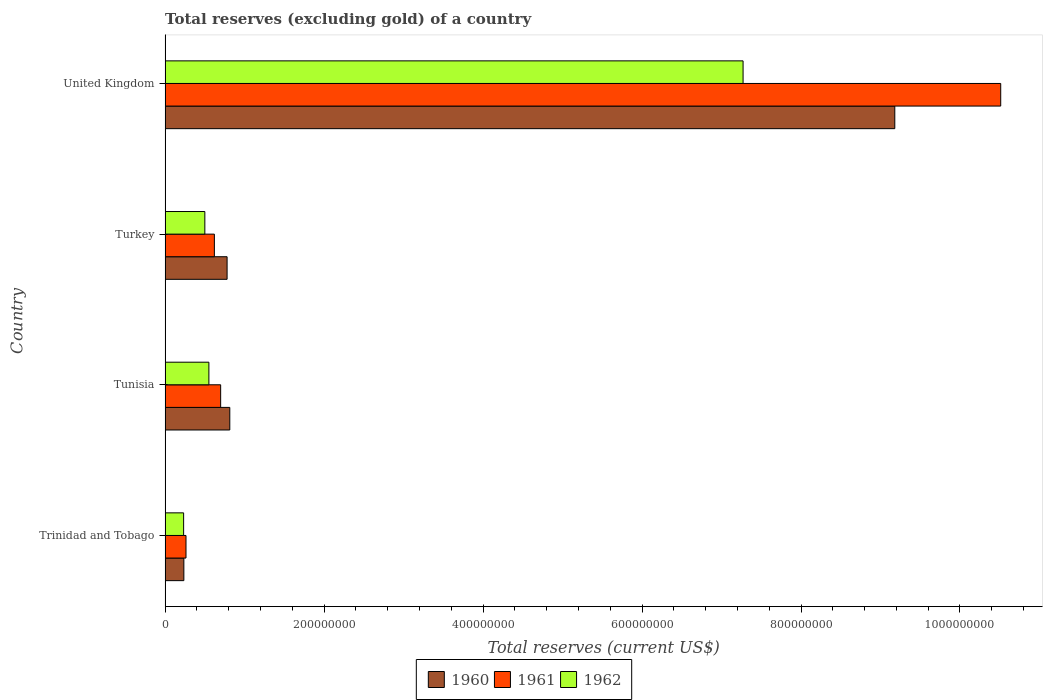How many different coloured bars are there?
Provide a short and direct response. 3. Are the number of bars on each tick of the Y-axis equal?
Provide a short and direct response. Yes. What is the total reserves (excluding gold) in 1962 in United Kingdom?
Keep it short and to the point. 7.27e+08. Across all countries, what is the maximum total reserves (excluding gold) in 1962?
Give a very brief answer. 7.27e+08. Across all countries, what is the minimum total reserves (excluding gold) in 1962?
Keep it short and to the point. 2.33e+07. In which country was the total reserves (excluding gold) in 1960 minimum?
Provide a succinct answer. Trinidad and Tobago. What is the total total reserves (excluding gold) in 1960 in the graph?
Your answer should be very brief. 1.10e+09. What is the difference between the total reserves (excluding gold) in 1962 in Trinidad and Tobago and that in Tunisia?
Make the answer very short. -3.18e+07. What is the difference between the total reserves (excluding gold) in 1960 in Tunisia and the total reserves (excluding gold) in 1962 in Trinidad and Tobago?
Offer a terse response. 5.81e+07. What is the average total reserves (excluding gold) in 1960 per country?
Give a very brief answer. 2.75e+08. What is the difference between the total reserves (excluding gold) in 1960 and total reserves (excluding gold) in 1962 in Turkey?
Make the answer very short. 2.80e+07. What is the ratio of the total reserves (excluding gold) in 1961 in Trinidad and Tobago to that in Tunisia?
Give a very brief answer. 0.38. Is the total reserves (excluding gold) in 1960 in Trinidad and Tobago less than that in Tunisia?
Provide a short and direct response. Yes. Is the difference between the total reserves (excluding gold) in 1960 in Trinidad and Tobago and Turkey greater than the difference between the total reserves (excluding gold) in 1962 in Trinidad and Tobago and Turkey?
Offer a very short reply. No. What is the difference between the highest and the second highest total reserves (excluding gold) in 1962?
Offer a terse response. 6.72e+08. What is the difference between the highest and the lowest total reserves (excluding gold) in 1961?
Your response must be concise. 1.02e+09. In how many countries, is the total reserves (excluding gold) in 1962 greater than the average total reserves (excluding gold) in 1962 taken over all countries?
Offer a terse response. 1. Is the sum of the total reserves (excluding gold) in 1962 in Trinidad and Tobago and United Kingdom greater than the maximum total reserves (excluding gold) in 1960 across all countries?
Offer a very short reply. No. How many bars are there?
Your response must be concise. 12. Are all the bars in the graph horizontal?
Your answer should be very brief. Yes. How many countries are there in the graph?
Your answer should be very brief. 4. What is the difference between two consecutive major ticks on the X-axis?
Keep it short and to the point. 2.00e+08. Are the values on the major ticks of X-axis written in scientific E-notation?
Provide a succinct answer. No. Does the graph contain grids?
Make the answer very short. No. Where does the legend appear in the graph?
Provide a succinct answer. Bottom center. How are the legend labels stacked?
Give a very brief answer. Horizontal. What is the title of the graph?
Ensure brevity in your answer.  Total reserves (excluding gold) of a country. Does "1989" appear as one of the legend labels in the graph?
Provide a short and direct response. No. What is the label or title of the X-axis?
Ensure brevity in your answer.  Total reserves (current US$). What is the label or title of the Y-axis?
Keep it short and to the point. Country. What is the Total reserves (current US$) of 1960 in Trinidad and Tobago?
Keep it short and to the point. 2.36e+07. What is the Total reserves (current US$) in 1961 in Trinidad and Tobago?
Offer a very short reply. 2.63e+07. What is the Total reserves (current US$) in 1962 in Trinidad and Tobago?
Keep it short and to the point. 2.33e+07. What is the Total reserves (current US$) of 1960 in Tunisia?
Your response must be concise. 8.14e+07. What is the Total reserves (current US$) in 1961 in Tunisia?
Your answer should be compact. 6.99e+07. What is the Total reserves (current US$) in 1962 in Tunisia?
Your response must be concise. 5.51e+07. What is the Total reserves (current US$) in 1960 in Turkey?
Ensure brevity in your answer.  7.80e+07. What is the Total reserves (current US$) of 1961 in Turkey?
Provide a short and direct response. 6.20e+07. What is the Total reserves (current US$) of 1960 in United Kingdom?
Provide a succinct answer. 9.18e+08. What is the Total reserves (current US$) in 1961 in United Kingdom?
Your answer should be very brief. 1.05e+09. What is the Total reserves (current US$) of 1962 in United Kingdom?
Provide a succinct answer. 7.27e+08. Across all countries, what is the maximum Total reserves (current US$) of 1960?
Your answer should be very brief. 9.18e+08. Across all countries, what is the maximum Total reserves (current US$) in 1961?
Provide a succinct answer. 1.05e+09. Across all countries, what is the maximum Total reserves (current US$) of 1962?
Provide a short and direct response. 7.27e+08. Across all countries, what is the minimum Total reserves (current US$) in 1960?
Provide a short and direct response. 2.36e+07. Across all countries, what is the minimum Total reserves (current US$) in 1961?
Keep it short and to the point. 2.63e+07. Across all countries, what is the minimum Total reserves (current US$) in 1962?
Make the answer very short. 2.33e+07. What is the total Total reserves (current US$) in 1960 in the graph?
Your answer should be compact. 1.10e+09. What is the total Total reserves (current US$) of 1961 in the graph?
Offer a very short reply. 1.21e+09. What is the total Total reserves (current US$) of 1962 in the graph?
Your answer should be compact. 8.56e+08. What is the difference between the Total reserves (current US$) of 1960 in Trinidad and Tobago and that in Tunisia?
Provide a short and direct response. -5.78e+07. What is the difference between the Total reserves (current US$) in 1961 in Trinidad and Tobago and that in Tunisia?
Your response must be concise. -4.36e+07. What is the difference between the Total reserves (current US$) in 1962 in Trinidad and Tobago and that in Tunisia?
Your response must be concise. -3.18e+07. What is the difference between the Total reserves (current US$) in 1960 in Trinidad and Tobago and that in Turkey?
Ensure brevity in your answer.  -5.44e+07. What is the difference between the Total reserves (current US$) in 1961 in Trinidad and Tobago and that in Turkey?
Provide a succinct answer. -3.57e+07. What is the difference between the Total reserves (current US$) of 1962 in Trinidad and Tobago and that in Turkey?
Ensure brevity in your answer.  -2.67e+07. What is the difference between the Total reserves (current US$) in 1960 in Trinidad and Tobago and that in United Kingdom?
Your answer should be very brief. -8.94e+08. What is the difference between the Total reserves (current US$) in 1961 in Trinidad and Tobago and that in United Kingdom?
Your answer should be very brief. -1.02e+09. What is the difference between the Total reserves (current US$) of 1962 in Trinidad and Tobago and that in United Kingdom?
Make the answer very short. -7.04e+08. What is the difference between the Total reserves (current US$) of 1960 in Tunisia and that in Turkey?
Your answer should be compact. 3.40e+06. What is the difference between the Total reserves (current US$) of 1961 in Tunisia and that in Turkey?
Offer a terse response. 7.90e+06. What is the difference between the Total reserves (current US$) in 1962 in Tunisia and that in Turkey?
Your answer should be very brief. 5.10e+06. What is the difference between the Total reserves (current US$) of 1960 in Tunisia and that in United Kingdom?
Provide a succinct answer. -8.37e+08. What is the difference between the Total reserves (current US$) of 1961 in Tunisia and that in United Kingdom?
Give a very brief answer. -9.81e+08. What is the difference between the Total reserves (current US$) of 1962 in Tunisia and that in United Kingdom?
Offer a terse response. -6.72e+08. What is the difference between the Total reserves (current US$) of 1960 in Turkey and that in United Kingdom?
Make the answer very short. -8.40e+08. What is the difference between the Total reserves (current US$) of 1961 in Turkey and that in United Kingdom?
Provide a succinct answer. -9.89e+08. What is the difference between the Total reserves (current US$) of 1962 in Turkey and that in United Kingdom?
Keep it short and to the point. -6.77e+08. What is the difference between the Total reserves (current US$) in 1960 in Trinidad and Tobago and the Total reserves (current US$) in 1961 in Tunisia?
Give a very brief answer. -4.63e+07. What is the difference between the Total reserves (current US$) of 1960 in Trinidad and Tobago and the Total reserves (current US$) of 1962 in Tunisia?
Your answer should be very brief. -3.15e+07. What is the difference between the Total reserves (current US$) of 1961 in Trinidad and Tobago and the Total reserves (current US$) of 1962 in Tunisia?
Your answer should be very brief. -2.88e+07. What is the difference between the Total reserves (current US$) of 1960 in Trinidad and Tobago and the Total reserves (current US$) of 1961 in Turkey?
Provide a succinct answer. -3.84e+07. What is the difference between the Total reserves (current US$) of 1960 in Trinidad and Tobago and the Total reserves (current US$) of 1962 in Turkey?
Give a very brief answer. -2.64e+07. What is the difference between the Total reserves (current US$) of 1961 in Trinidad and Tobago and the Total reserves (current US$) of 1962 in Turkey?
Provide a short and direct response. -2.37e+07. What is the difference between the Total reserves (current US$) in 1960 in Trinidad and Tobago and the Total reserves (current US$) in 1961 in United Kingdom?
Provide a short and direct response. -1.03e+09. What is the difference between the Total reserves (current US$) of 1960 in Trinidad and Tobago and the Total reserves (current US$) of 1962 in United Kingdom?
Provide a succinct answer. -7.04e+08. What is the difference between the Total reserves (current US$) of 1961 in Trinidad and Tobago and the Total reserves (current US$) of 1962 in United Kingdom?
Offer a terse response. -7.01e+08. What is the difference between the Total reserves (current US$) in 1960 in Tunisia and the Total reserves (current US$) in 1961 in Turkey?
Offer a terse response. 1.94e+07. What is the difference between the Total reserves (current US$) of 1960 in Tunisia and the Total reserves (current US$) of 1962 in Turkey?
Make the answer very short. 3.14e+07. What is the difference between the Total reserves (current US$) in 1961 in Tunisia and the Total reserves (current US$) in 1962 in Turkey?
Keep it short and to the point. 1.99e+07. What is the difference between the Total reserves (current US$) in 1960 in Tunisia and the Total reserves (current US$) in 1961 in United Kingdom?
Offer a very short reply. -9.70e+08. What is the difference between the Total reserves (current US$) of 1960 in Tunisia and the Total reserves (current US$) of 1962 in United Kingdom?
Provide a short and direct response. -6.46e+08. What is the difference between the Total reserves (current US$) of 1961 in Tunisia and the Total reserves (current US$) of 1962 in United Kingdom?
Offer a very short reply. -6.57e+08. What is the difference between the Total reserves (current US$) of 1960 in Turkey and the Total reserves (current US$) of 1961 in United Kingdom?
Provide a short and direct response. -9.73e+08. What is the difference between the Total reserves (current US$) of 1960 in Turkey and the Total reserves (current US$) of 1962 in United Kingdom?
Provide a short and direct response. -6.49e+08. What is the difference between the Total reserves (current US$) in 1961 in Turkey and the Total reserves (current US$) in 1962 in United Kingdom?
Your response must be concise. -6.65e+08. What is the average Total reserves (current US$) in 1960 per country?
Your answer should be very brief. 2.75e+08. What is the average Total reserves (current US$) in 1961 per country?
Your answer should be compact. 3.02e+08. What is the average Total reserves (current US$) in 1962 per country?
Offer a very short reply. 2.14e+08. What is the difference between the Total reserves (current US$) in 1960 and Total reserves (current US$) in 1961 in Trinidad and Tobago?
Your response must be concise. -2.70e+06. What is the difference between the Total reserves (current US$) of 1960 and Total reserves (current US$) of 1962 in Trinidad and Tobago?
Your response must be concise. 3.00e+05. What is the difference between the Total reserves (current US$) in 1960 and Total reserves (current US$) in 1961 in Tunisia?
Offer a very short reply. 1.15e+07. What is the difference between the Total reserves (current US$) in 1960 and Total reserves (current US$) in 1962 in Tunisia?
Provide a short and direct response. 2.63e+07. What is the difference between the Total reserves (current US$) in 1961 and Total reserves (current US$) in 1962 in Tunisia?
Ensure brevity in your answer.  1.48e+07. What is the difference between the Total reserves (current US$) in 1960 and Total reserves (current US$) in 1961 in Turkey?
Give a very brief answer. 1.60e+07. What is the difference between the Total reserves (current US$) in 1960 and Total reserves (current US$) in 1962 in Turkey?
Your answer should be very brief. 2.80e+07. What is the difference between the Total reserves (current US$) in 1960 and Total reserves (current US$) in 1961 in United Kingdom?
Your answer should be compact. -1.33e+08. What is the difference between the Total reserves (current US$) of 1960 and Total reserves (current US$) of 1962 in United Kingdom?
Provide a succinct answer. 1.91e+08. What is the difference between the Total reserves (current US$) of 1961 and Total reserves (current US$) of 1962 in United Kingdom?
Offer a terse response. 3.24e+08. What is the ratio of the Total reserves (current US$) of 1960 in Trinidad and Tobago to that in Tunisia?
Offer a very short reply. 0.29. What is the ratio of the Total reserves (current US$) of 1961 in Trinidad and Tobago to that in Tunisia?
Ensure brevity in your answer.  0.38. What is the ratio of the Total reserves (current US$) in 1962 in Trinidad and Tobago to that in Tunisia?
Provide a succinct answer. 0.42. What is the ratio of the Total reserves (current US$) of 1960 in Trinidad and Tobago to that in Turkey?
Your answer should be very brief. 0.3. What is the ratio of the Total reserves (current US$) of 1961 in Trinidad and Tobago to that in Turkey?
Provide a short and direct response. 0.42. What is the ratio of the Total reserves (current US$) in 1962 in Trinidad and Tobago to that in Turkey?
Your answer should be very brief. 0.47. What is the ratio of the Total reserves (current US$) of 1960 in Trinidad and Tobago to that in United Kingdom?
Give a very brief answer. 0.03. What is the ratio of the Total reserves (current US$) in 1961 in Trinidad and Tobago to that in United Kingdom?
Give a very brief answer. 0.03. What is the ratio of the Total reserves (current US$) in 1962 in Trinidad and Tobago to that in United Kingdom?
Keep it short and to the point. 0.03. What is the ratio of the Total reserves (current US$) of 1960 in Tunisia to that in Turkey?
Your answer should be compact. 1.04. What is the ratio of the Total reserves (current US$) of 1961 in Tunisia to that in Turkey?
Offer a terse response. 1.13. What is the ratio of the Total reserves (current US$) of 1962 in Tunisia to that in Turkey?
Make the answer very short. 1.1. What is the ratio of the Total reserves (current US$) in 1960 in Tunisia to that in United Kingdom?
Ensure brevity in your answer.  0.09. What is the ratio of the Total reserves (current US$) of 1961 in Tunisia to that in United Kingdom?
Offer a terse response. 0.07. What is the ratio of the Total reserves (current US$) of 1962 in Tunisia to that in United Kingdom?
Give a very brief answer. 0.08. What is the ratio of the Total reserves (current US$) of 1960 in Turkey to that in United Kingdom?
Your answer should be compact. 0.09. What is the ratio of the Total reserves (current US$) in 1961 in Turkey to that in United Kingdom?
Your response must be concise. 0.06. What is the ratio of the Total reserves (current US$) of 1962 in Turkey to that in United Kingdom?
Your answer should be compact. 0.07. What is the difference between the highest and the second highest Total reserves (current US$) of 1960?
Your answer should be very brief. 8.37e+08. What is the difference between the highest and the second highest Total reserves (current US$) of 1961?
Offer a terse response. 9.81e+08. What is the difference between the highest and the second highest Total reserves (current US$) in 1962?
Your answer should be compact. 6.72e+08. What is the difference between the highest and the lowest Total reserves (current US$) of 1960?
Your answer should be very brief. 8.94e+08. What is the difference between the highest and the lowest Total reserves (current US$) of 1961?
Make the answer very short. 1.02e+09. What is the difference between the highest and the lowest Total reserves (current US$) in 1962?
Offer a very short reply. 7.04e+08. 